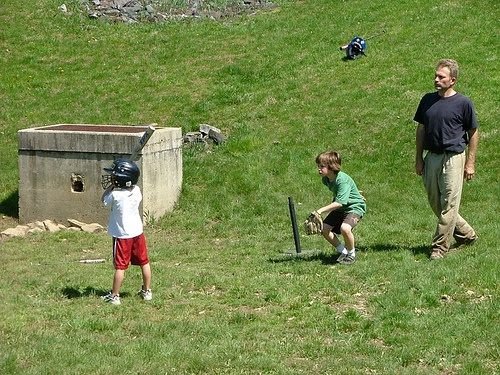Describe the objects in this image and their specific colors. I can see people in darkgreen, black, gray, and tan tones, people in darkgreen, white, olive, black, and gray tones, people in darkgreen, black, gray, and olive tones, baseball glove in darkgreen, black, tan, and gray tones, and baseball bat in darkgreen, gray, black, and darkgray tones in this image. 